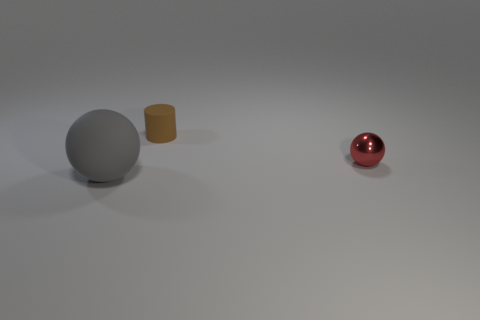There is a object that is the same size as the red sphere; what color is it?
Provide a succinct answer. Brown. How many balls are there?
Provide a short and direct response. 2. Does the small red sphere to the right of the brown rubber cylinder have the same material as the gray thing?
Keep it short and to the point. No. What is the material of the object that is both on the left side of the tiny metallic object and behind the large rubber thing?
Your answer should be compact. Rubber. There is a sphere left of the sphere to the right of the large rubber object; what is it made of?
Offer a terse response. Rubber. There is a object in front of the tiny thing in front of the object behind the tiny red object; what is its size?
Keep it short and to the point. Large. How many big gray balls have the same material as the tiny ball?
Keep it short and to the point. 0. What color is the rubber object that is in front of the matte object that is right of the big gray object?
Provide a succinct answer. Gray. How many objects are either small things or matte things that are in front of the small brown object?
Your answer should be very brief. 3. How many gray objects are either big things or metallic objects?
Your answer should be compact. 1. 